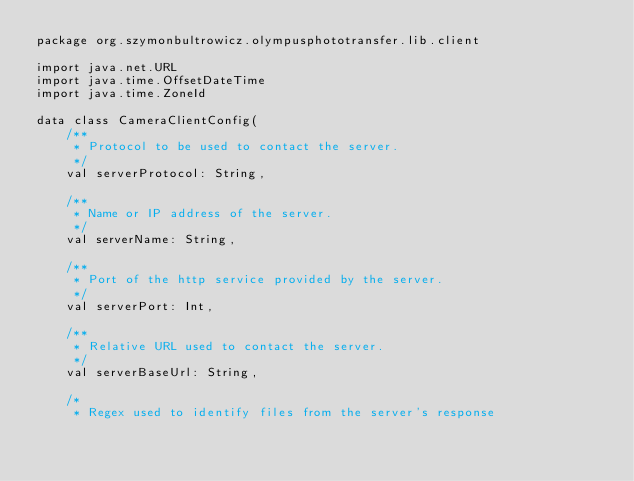<code> <loc_0><loc_0><loc_500><loc_500><_Kotlin_>package org.szymonbultrowicz.olympusphototransfer.lib.client

import java.net.URL
import java.time.OffsetDateTime
import java.time.ZoneId

data class CameraClientConfig(
    /**
     * Protocol to be used to contact the server.
     */
    val serverProtocol: String,

    /**
     * Name or IP address of the server.
     */
    val serverName: String,

    /**
     * Port of the http service provided by the server.
     */
    val serverPort: Int,

    /**
     * Relative URL used to contact the server.
     */
    val serverBaseUrl: String,

    /*
     * Regex used to identify files from the server's response</code> 